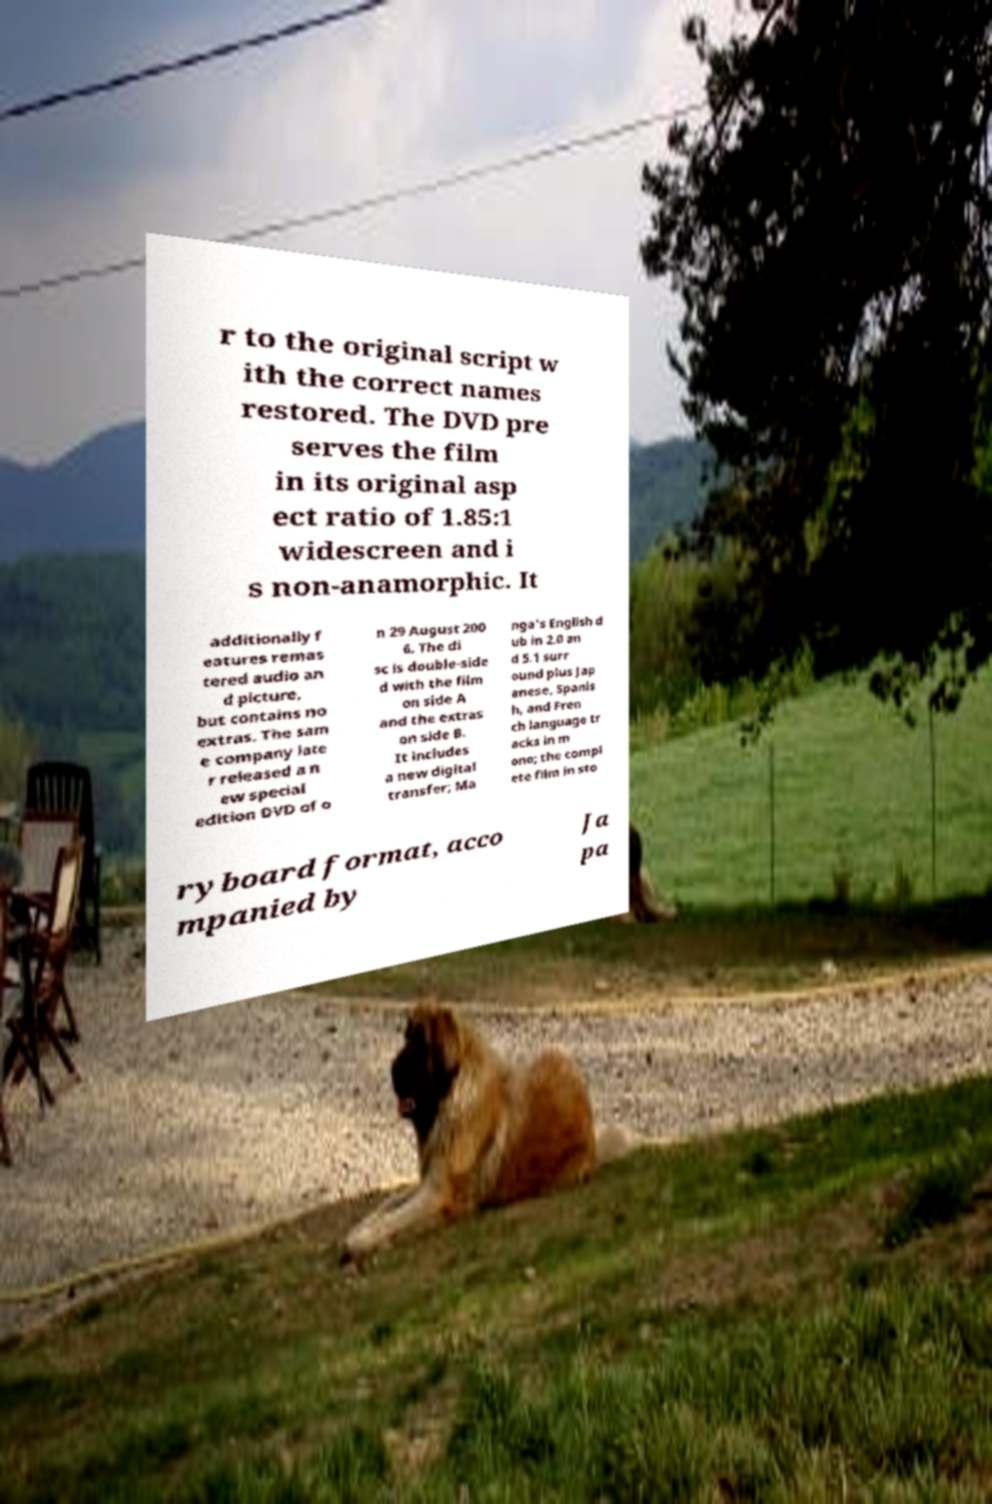What messages or text are displayed in this image? I need them in a readable, typed format. r to the original script w ith the correct names restored. The DVD pre serves the film in its original asp ect ratio of 1.85:1 widescreen and i s non-anamorphic. It additionally f eatures remas tered audio an d picture, but contains no extras. The sam e company late r released a n ew special edition DVD of o n 29 August 200 6. The di sc is double-side d with the film on side A and the extras on side B. It includes a new digital transfer; Ma nga's English d ub in 2.0 an d 5.1 surr ound plus Jap anese, Spanis h, and Fren ch language tr acks in m ono; the compl ete film in sto ryboard format, acco mpanied by Ja pa 